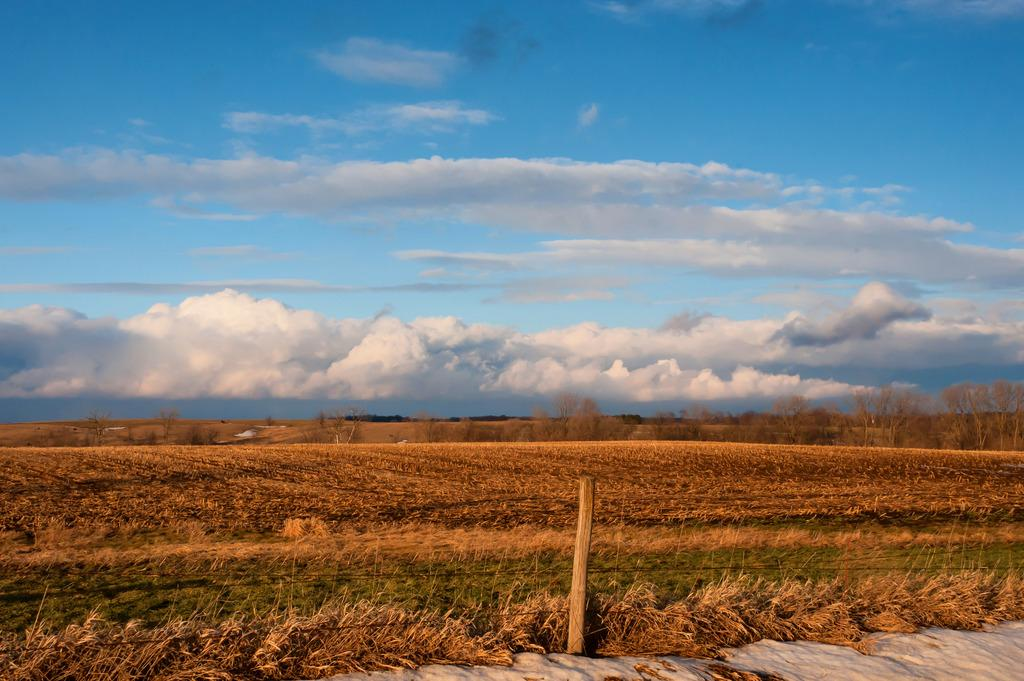What is the main object in the image? There is a pole in the image. What type of surface is under the pole? There is grass on the ground in the image. What can be seen in the distance behind the pole? There are trees in the background of the image. What is visible above the trees in the image? The sky is visible in the background of the image, and clouds are present in the sky. What kind of trouble is the dad having with the carpenter in the image? There is no dad, carpenter, or any indication of trouble in the image; it only features a pole, grass, trees, and the sky with clouds. 